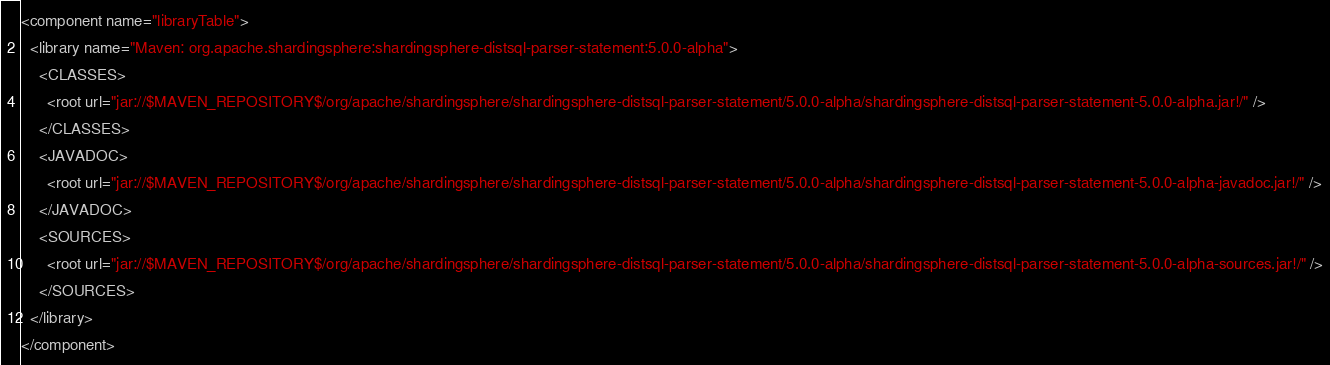Convert code to text. <code><loc_0><loc_0><loc_500><loc_500><_XML_><component name="libraryTable">
  <library name="Maven: org.apache.shardingsphere:shardingsphere-distsql-parser-statement:5.0.0-alpha">
    <CLASSES>
      <root url="jar://$MAVEN_REPOSITORY$/org/apache/shardingsphere/shardingsphere-distsql-parser-statement/5.0.0-alpha/shardingsphere-distsql-parser-statement-5.0.0-alpha.jar!/" />
    </CLASSES>
    <JAVADOC>
      <root url="jar://$MAVEN_REPOSITORY$/org/apache/shardingsphere/shardingsphere-distsql-parser-statement/5.0.0-alpha/shardingsphere-distsql-parser-statement-5.0.0-alpha-javadoc.jar!/" />
    </JAVADOC>
    <SOURCES>
      <root url="jar://$MAVEN_REPOSITORY$/org/apache/shardingsphere/shardingsphere-distsql-parser-statement/5.0.0-alpha/shardingsphere-distsql-parser-statement-5.0.0-alpha-sources.jar!/" />
    </SOURCES>
  </library>
</component></code> 